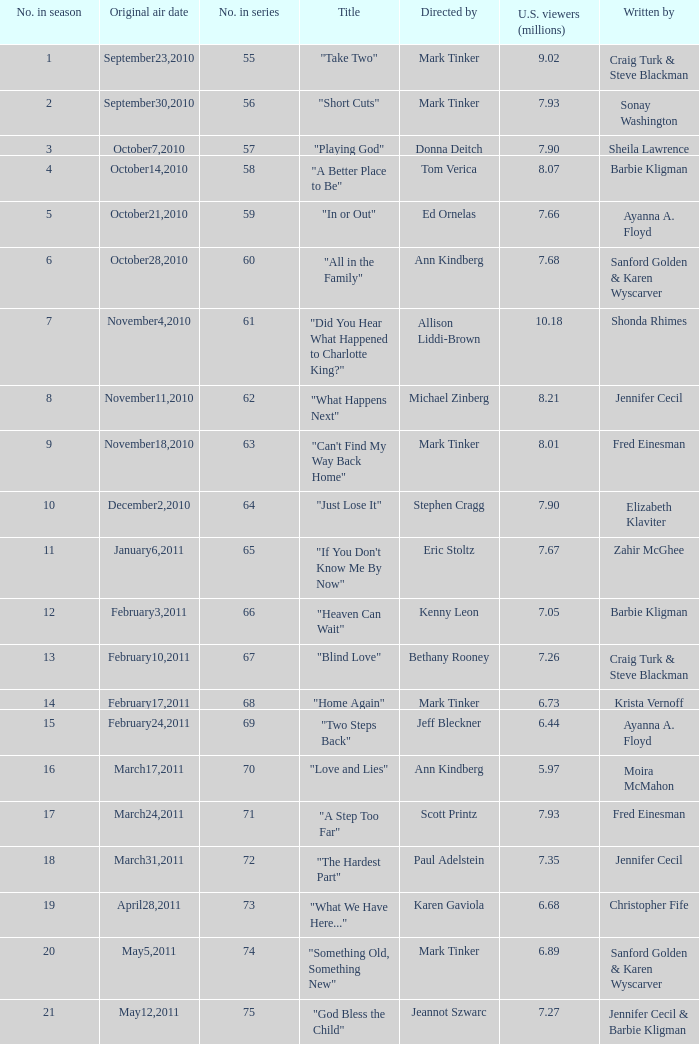What number episode in the season was directed by Paul Adelstein?  18.0. Could you parse the entire table? {'header': ['No. in season', 'Original air date', 'No. in series', 'Title', 'Directed by', 'U.S. viewers (millions)', 'Written by'], 'rows': [['1', 'September23,2010', '55', '"Take Two"', 'Mark Tinker', '9.02', 'Craig Turk & Steve Blackman'], ['2', 'September30,2010', '56', '"Short Cuts"', 'Mark Tinker', '7.93', 'Sonay Washington'], ['3', 'October7,2010', '57', '"Playing God"', 'Donna Deitch', '7.90', 'Sheila Lawrence'], ['4', 'October14,2010', '58', '"A Better Place to Be"', 'Tom Verica', '8.07', 'Barbie Kligman'], ['5', 'October21,2010', '59', '"In or Out"', 'Ed Ornelas', '7.66', 'Ayanna A. Floyd'], ['6', 'October28,2010', '60', '"All in the Family"', 'Ann Kindberg', '7.68', 'Sanford Golden & Karen Wyscarver'], ['7', 'November4,2010', '61', '"Did You Hear What Happened to Charlotte King?"', 'Allison Liddi-Brown', '10.18', 'Shonda Rhimes'], ['8', 'November11,2010', '62', '"What Happens Next"', 'Michael Zinberg', '8.21', 'Jennifer Cecil'], ['9', 'November18,2010', '63', '"Can\'t Find My Way Back Home"', 'Mark Tinker', '8.01', 'Fred Einesman'], ['10', 'December2,2010', '64', '"Just Lose It"', 'Stephen Cragg', '7.90', 'Elizabeth Klaviter'], ['11', 'January6,2011', '65', '"If You Don\'t Know Me By Now"', 'Eric Stoltz', '7.67', 'Zahir McGhee'], ['12', 'February3,2011', '66', '"Heaven Can Wait"', 'Kenny Leon', '7.05', 'Barbie Kligman'], ['13', 'February10,2011', '67', '"Blind Love"', 'Bethany Rooney', '7.26', 'Craig Turk & Steve Blackman'], ['14', 'February17,2011', '68', '"Home Again"', 'Mark Tinker', '6.73', 'Krista Vernoff'], ['15', 'February24,2011', '69', '"Two Steps Back"', 'Jeff Bleckner', '6.44', 'Ayanna A. Floyd'], ['16', 'March17,2011', '70', '"Love and Lies"', 'Ann Kindberg', '5.97', 'Moira McMahon'], ['17', 'March24,2011', '71', '"A Step Too Far"', 'Scott Printz', '7.93', 'Fred Einesman'], ['18', 'March31,2011', '72', '"The Hardest Part"', 'Paul Adelstein', '7.35', 'Jennifer Cecil'], ['19', 'April28,2011', '73', '"What We Have Here..."', 'Karen Gaviola', '6.68', 'Christopher Fife'], ['20', 'May5,2011', '74', '"Something Old, Something New"', 'Mark Tinker', '6.89', 'Sanford Golden & Karen Wyscarver'], ['21', 'May12,2011', '75', '"God Bless the Child"', 'Jeannot Szwarc', '7.27', 'Jennifer Cecil & Barbie Kligman']]} 